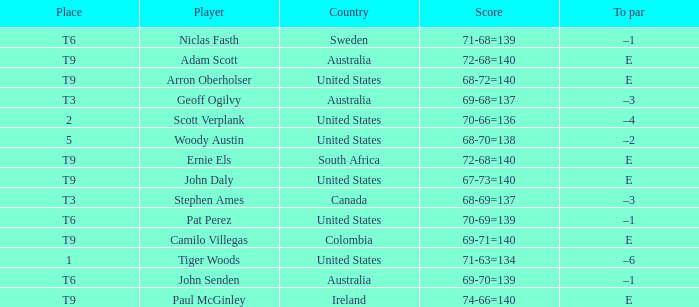Which player has a to par of e and a score of 67-73=140? John Daly. 